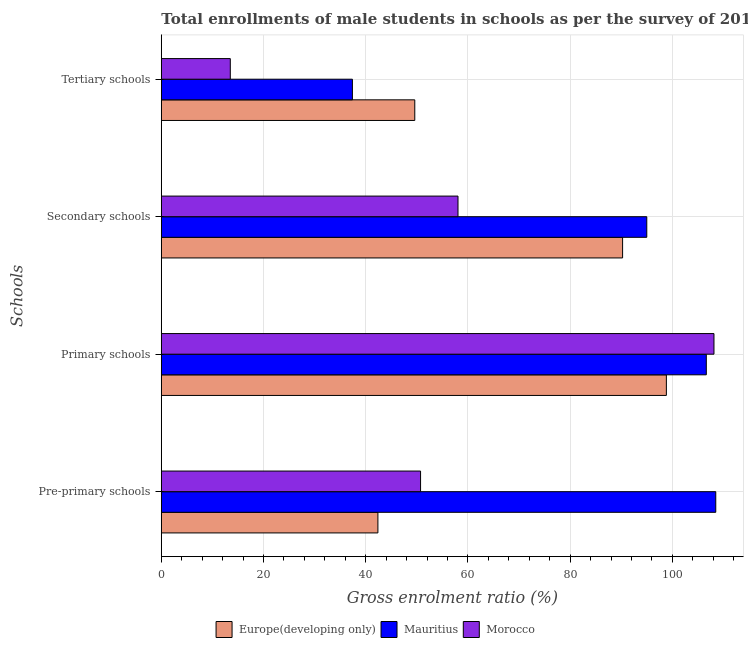How many different coloured bars are there?
Your response must be concise. 3. How many groups of bars are there?
Your answer should be compact. 4. What is the label of the 2nd group of bars from the top?
Make the answer very short. Secondary schools. What is the gross enrolment ratio(male) in primary schools in Morocco?
Offer a very short reply. 108.13. Across all countries, what is the maximum gross enrolment ratio(male) in pre-primary schools?
Make the answer very short. 108.48. Across all countries, what is the minimum gross enrolment ratio(male) in pre-primary schools?
Give a very brief answer. 42.37. In which country was the gross enrolment ratio(male) in primary schools maximum?
Keep it short and to the point. Morocco. In which country was the gross enrolment ratio(male) in primary schools minimum?
Your answer should be very brief. Europe(developing only). What is the total gross enrolment ratio(male) in secondary schools in the graph?
Offer a terse response. 243.27. What is the difference between the gross enrolment ratio(male) in tertiary schools in Morocco and that in Mauritius?
Ensure brevity in your answer.  -23.89. What is the difference between the gross enrolment ratio(male) in pre-primary schools in Europe(developing only) and the gross enrolment ratio(male) in primary schools in Mauritius?
Keep it short and to the point. -64.25. What is the average gross enrolment ratio(male) in tertiary schools per country?
Offer a terse response. 33.49. What is the difference between the gross enrolment ratio(male) in pre-primary schools and gross enrolment ratio(male) in tertiary schools in Morocco?
Your answer should be very brief. 37.22. What is the ratio of the gross enrolment ratio(male) in tertiary schools in Morocco to that in Mauritius?
Offer a terse response. 0.36. Is the gross enrolment ratio(male) in pre-primary schools in Morocco less than that in Mauritius?
Provide a short and direct response. Yes. What is the difference between the highest and the second highest gross enrolment ratio(male) in tertiary schools?
Give a very brief answer. 12.2. What is the difference between the highest and the lowest gross enrolment ratio(male) in primary schools?
Provide a succinct answer. 9.31. What does the 3rd bar from the top in Pre-primary schools represents?
Your answer should be compact. Europe(developing only). What does the 3rd bar from the bottom in Pre-primary schools represents?
Your answer should be very brief. Morocco. Is it the case that in every country, the sum of the gross enrolment ratio(male) in pre-primary schools and gross enrolment ratio(male) in primary schools is greater than the gross enrolment ratio(male) in secondary schools?
Your response must be concise. Yes. Are all the bars in the graph horizontal?
Offer a terse response. Yes. How many countries are there in the graph?
Offer a terse response. 3. What is the difference between two consecutive major ticks on the X-axis?
Your response must be concise. 20. Are the values on the major ticks of X-axis written in scientific E-notation?
Make the answer very short. No. Does the graph contain grids?
Your answer should be compact. Yes. How are the legend labels stacked?
Provide a short and direct response. Horizontal. What is the title of the graph?
Your answer should be very brief. Total enrollments of male students in schools as per the survey of 2010 conducted in different countries. Does "Honduras" appear as one of the legend labels in the graph?
Your response must be concise. No. What is the label or title of the Y-axis?
Provide a succinct answer. Schools. What is the Gross enrolment ratio (%) of Europe(developing only) in Pre-primary schools?
Your answer should be compact. 42.37. What is the Gross enrolment ratio (%) of Mauritius in Pre-primary schools?
Ensure brevity in your answer.  108.48. What is the Gross enrolment ratio (%) of Morocco in Pre-primary schools?
Ensure brevity in your answer.  50.72. What is the Gross enrolment ratio (%) in Europe(developing only) in Primary schools?
Offer a terse response. 98.82. What is the Gross enrolment ratio (%) of Mauritius in Primary schools?
Provide a short and direct response. 106.63. What is the Gross enrolment ratio (%) in Morocco in Primary schools?
Provide a succinct answer. 108.13. What is the Gross enrolment ratio (%) of Europe(developing only) in Secondary schools?
Provide a short and direct response. 90.25. What is the Gross enrolment ratio (%) of Mauritius in Secondary schools?
Give a very brief answer. 94.98. What is the Gross enrolment ratio (%) in Morocco in Secondary schools?
Keep it short and to the point. 58.05. What is the Gross enrolment ratio (%) in Europe(developing only) in Tertiary schools?
Provide a succinct answer. 49.59. What is the Gross enrolment ratio (%) of Mauritius in Tertiary schools?
Make the answer very short. 37.39. What is the Gross enrolment ratio (%) in Morocco in Tertiary schools?
Keep it short and to the point. 13.5. Across all Schools, what is the maximum Gross enrolment ratio (%) in Europe(developing only)?
Make the answer very short. 98.82. Across all Schools, what is the maximum Gross enrolment ratio (%) of Mauritius?
Offer a very short reply. 108.48. Across all Schools, what is the maximum Gross enrolment ratio (%) of Morocco?
Give a very brief answer. 108.13. Across all Schools, what is the minimum Gross enrolment ratio (%) of Europe(developing only)?
Your response must be concise. 42.37. Across all Schools, what is the minimum Gross enrolment ratio (%) in Mauritius?
Keep it short and to the point. 37.39. Across all Schools, what is the minimum Gross enrolment ratio (%) in Morocco?
Your response must be concise. 13.5. What is the total Gross enrolment ratio (%) of Europe(developing only) in the graph?
Give a very brief answer. 281.03. What is the total Gross enrolment ratio (%) of Mauritius in the graph?
Offer a terse response. 347.47. What is the total Gross enrolment ratio (%) of Morocco in the graph?
Give a very brief answer. 230.39. What is the difference between the Gross enrolment ratio (%) of Europe(developing only) in Pre-primary schools and that in Primary schools?
Make the answer very short. -56.44. What is the difference between the Gross enrolment ratio (%) of Mauritius in Pre-primary schools and that in Primary schools?
Offer a very short reply. 1.85. What is the difference between the Gross enrolment ratio (%) of Morocco in Pre-primary schools and that in Primary schools?
Give a very brief answer. -57.41. What is the difference between the Gross enrolment ratio (%) of Europe(developing only) in Pre-primary schools and that in Secondary schools?
Keep it short and to the point. -47.87. What is the difference between the Gross enrolment ratio (%) of Mauritius in Pre-primary schools and that in Secondary schools?
Your response must be concise. 13.5. What is the difference between the Gross enrolment ratio (%) in Morocco in Pre-primary schools and that in Secondary schools?
Give a very brief answer. -7.32. What is the difference between the Gross enrolment ratio (%) in Europe(developing only) in Pre-primary schools and that in Tertiary schools?
Your response must be concise. -7.21. What is the difference between the Gross enrolment ratio (%) in Mauritius in Pre-primary schools and that in Tertiary schools?
Keep it short and to the point. 71.09. What is the difference between the Gross enrolment ratio (%) of Morocco in Pre-primary schools and that in Tertiary schools?
Your answer should be compact. 37.22. What is the difference between the Gross enrolment ratio (%) in Europe(developing only) in Primary schools and that in Secondary schools?
Provide a succinct answer. 8.57. What is the difference between the Gross enrolment ratio (%) of Mauritius in Primary schools and that in Secondary schools?
Offer a very short reply. 11.65. What is the difference between the Gross enrolment ratio (%) in Morocco in Primary schools and that in Secondary schools?
Your answer should be very brief. 50.08. What is the difference between the Gross enrolment ratio (%) in Europe(developing only) in Primary schools and that in Tertiary schools?
Your response must be concise. 49.23. What is the difference between the Gross enrolment ratio (%) of Mauritius in Primary schools and that in Tertiary schools?
Offer a very short reply. 69.24. What is the difference between the Gross enrolment ratio (%) in Morocco in Primary schools and that in Tertiary schools?
Your response must be concise. 94.63. What is the difference between the Gross enrolment ratio (%) in Europe(developing only) in Secondary schools and that in Tertiary schools?
Offer a terse response. 40.66. What is the difference between the Gross enrolment ratio (%) in Mauritius in Secondary schools and that in Tertiary schools?
Provide a short and direct response. 57.59. What is the difference between the Gross enrolment ratio (%) in Morocco in Secondary schools and that in Tertiary schools?
Your answer should be compact. 44.55. What is the difference between the Gross enrolment ratio (%) of Europe(developing only) in Pre-primary schools and the Gross enrolment ratio (%) of Mauritius in Primary schools?
Give a very brief answer. -64.25. What is the difference between the Gross enrolment ratio (%) in Europe(developing only) in Pre-primary schools and the Gross enrolment ratio (%) in Morocco in Primary schools?
Your answer should be compact. -65.75. What is the difference between the Gross enrolment ratio (%) in Mauritius in Pre-primary schools and the Gross enrolment ratio (%) in Morocco in Primary schools?
Ensure brevity in your answer.  0.35. What is the difference between the Gross enrolment ratio (%) in Europe(developing only) in Pre-primary schools and the Gross enrolment ratio (%) in Mauritius in Secondary schools?
Your answer should be very brief. -52.61. What is the difference between the Gross enrolment ratio (%) in Europe(developing only) in Pre-primary schools and the Gross enrolment ratio (%) in Morocco in Secondary schools?
Your answer should be compact. -15.67. What is the difference between the Gross enrolment ratio (%) of Mauritius in Pre-primary schools and the Gross enrolment ratio (%) of Morocco in Secondary schools?
Your answer should be compact. 50.43. What is the difference between the Gross enrolment ratio (%) in Europe(developing only) in Pre-primary schools and the Gross enrolment ratio (%) in Mauritius in Tertiary schools?
Offer a very short reply. 4.99. What is the difference between the Gross enrolment ratio (%) in Europe(developing only) in Pre-primary schools and the Gross enrolment ratio (%) in Morocco in Tertiary schools?
Provide a succinct answer. 28.88. What is the difference between the Gross enrolment ratio (%) in Mauritius in Pre-primary schools and the Gross enrolment ratio (%) in Morocco in Tertiary schools?
Make the answer very short. 94.98. What is the difference between the Gross enrolment ratio (%) of Europe(developing only) in Primary schools and the Gross enrolment ratio (%) of Mauritius in Secondary schools?
Make the answer very short. 3.83. What is the difference between the Gross enrolment ratio (%) of Europe(developing only) in Primary schools and the Gross enrolment ratio (%) of Morocco in Secondary schools?
Your answer should be compact. 40.77. What is the difference between the Gross enrolment ratio (%) of Mauritius in Primary schools and the Gross enrolment ratio (%) of Morocco in Secondary schools?
Give a very brief answer. 48.58. What is the difference between the Gross enrolment ratio (%) in Europe(developing only) in Primary schools and the Gross enrolment ratio (%) in Mauritius in Tertiary schools?
Make the answer very short. 61.43. What is the difference between the Gross enrolment ratio (%) in Europe(developing only) in Primary schools and the Gross enrolment ratio (%) in Morocco in Tertiary schools?
Ensure brevity in your answer.  85.32. What is the difference between the Gross enrolment ratio (%) in Mauritius in Primary schools and the Gross enrolment ratio (%) in Morocco in Tertiary schools?
Provide a short and direct response. 93.13. What is the difference between the Gross enrolment ratio (%) of Europe(developing only) in Secondary schools and the Gross enrolment ratio (%) of Mauritius in Tertiary schools?
Offer a very short reply. 52.86. What is the difference between the Gross enrolment ratio (%) in Europe(developing only) in Secondary schools and the Gross enrolment ratio (%) in Morocco in Tertiary schools?
Make the answer very short. 76.75. What is the difference between the Gross enrolment ratio (%) of Mauritius in Secondary schools and the Gross enrolment ratio (%) of Morocco in Tertiary schools?
Provide a short and direct response. 81.48. What is the average Gross enrolment ratio (%) of Europe(developing only) per Schools?
Your response must be concise. 70.26. What is the average Gross enrolment ratio (%) in Mauritius per Schools?
Ensure brevity in your answer.  86.87. What is the average Gross enrolment ratio (%) in Morocco per Schools?
Keep it short and to the point. 57.6. What is the difference between the Gross enrolment ratio (%) in Europe(developing only) and Gross enrolment ratio (%) in Mauritius in Pre-primary schools?
Provide a short and direct response. -66.1. What is the difference between the Gross enrolment ratio (%) in Europe(developing only) and Gross enrolment ratio (%) in Morocco in Pre-primary schools?
Your answer should be very brief. -8.35. What is the difference between the Gross enrolment ratio (%) of Mauritius and Gross enrolment ratio (%) of Morocco in Pre-primary schools?
Offer a very short reply. 57.76. What is the difference between the Gross enrolment ratio (%) in Europe(developing only) and Gross enrolment ratio (%) in Mauritius in Primary schools?
Offer a very short reply. -7.81. What is the difference between the Gross enrolment ratio (%) of Europe(developing only) and Gross enrolment ratio (%) of Morocco in Primary schools?
Your answer should be very brief. -9.31. What is the difference between the Gross enrolment ratio (%) in Mauritius and Gross enrolment ratio (%) in Morocco in Primary schools?
Make the answer very short. -1.5. What is the difference between the Gross enrolment ratio (%) in Europe(developing only) and Gross enrolment ratio (%) in Mauritius in Secondary schools?
Offer a terse response. -4.73. What is the difference between the Gross enrolment ratio (%) in Europe(developing only) and Gross enrolment ratio (%) in Morocco in Secondary schools?
Provide a short and direct response. 32.2. What is the difference between the Gross enrolment ratio (%) in Mauritius and Gross enrolment ratio (%) in Morocco in Secondary schools?
Your answer should be compact. 36.94. What is the difference between the Gross enrolment ratio (%) of Europe(developing only) and Gross enrolment ratio (%) of Mauritius in Tertiary schools?
Your response must be concise. 12.2. What is the difference between the Gross enrolment ratio (%) of Europe(developing only) and Gross enrolment ratio (%) of Morocco in Tertiary schools?
Make the answer very short. 36.09. What is the difference between the Gross enrolment ratio (%) in Mauritius and Gross enrolment ratio (%) in Morocco in Tertiary schools?
Provide a short and direct response. 23.89. What is the ratio of the Gross enrolment ratio (%) in Europe(developing only) in Pre-primary schools to that in Primary schools?
Your answer should be compact. 0.43. What is the ratio of the Gross enrolment ratio (%) in Mauritius in Pre-primary schools to that in Primary schools?
Offer a very short reply. 1.02. What is the ratio of the Gross enrolment ratio (%) in Morocco in Pre-primary schools to that in Primary schools?
Your answer should be compact. 0.47. What is the ratio of the Gross enrolment ratio (%) of Europe(developing only) in Pre-primary schools to that in Secondary schools?
Give a very brief answer. 0.47. What is the ratio of the Gross enrolment ratio (%) of Mauritius in Pre-primary schools to that in Secondary schools?
Provide a short and direct response. 1.14. What is the ratio of the Gross enrolment ratio (%) in Morocco in Pre-primary schools to that in Secondary schools?
Offer a very short reply. 0.87. What is the ratio of the Gross enrolment ratio (%) of Europe(developing only) in Pre-primary schools to that in Tertiary schools?
Your answer should be compact. 0.85. What is the ratio of the Gross enrolment ratio (%) in Mauritius in Pre-primary schools to that in Tertiary schools?
Offer a terse response. 2.9. What is the ratio of the Gross enrolment ratio (%) in Morocco in Pre-primary schools to that in Tertiary schools?
Offer a very short reply. 3.76. What is the ratio of the Gross enrolment ratio (%) of Europe(developing only) in Primary schools to that in Secondary schools?
Make the answer very short. 1.09. What is the ratio of the Gross enrolment ratio (%) of Mauritius in Primary schools to that in Secondary schools?
Ensure brevity in your answer.  1.12. What is the ratio of the Gross enrolment ratio (%) in Morocco in Primary schools to that in Secondary schools?
Make the answer very short. 1.86. What is the ratio of the Gross enrolment ratio (%) in Europe(developing only) in Primary schools to that in Tertiary schools?
Provide a succinct answer. 1.99. What is the ratio of the Gross enrolment ratio (%) in Mauritius in Primary schools to that in Tertiary schools?
Offer a terse response. 2.85. What is the ratio of the Gross enrolment ratio (%) of Morocco in Primary schools to that in Tertiary schools?
Your answer should be compact. 8.01. What is the ratio of the Gross enrolment ratio (%) of Europe(developing only) in Secondary schools to that in Tertiary schools?
Provide a short and direct response. 1.82. What is the ratio of the Gross enrolment ratio (%) of Mauritius in Secondary schools to that in Tertiary schools?
Your answer should be very brief. 2.54. What is the ratio of the Gross enrolment ratio (%) in Morocco in Secondary schools to that in Tertiary schools?
Your answer should be very brief. 4.3. What is the difference between the highest and the second highest Gross enrolment ratio (%) in Europe(developing only)?
Provide a short and direct response. 8.57. What is the difference between the highest and the second highest Gross enrolment ratio (%) of Mauritius?
Keep it short and to the point. 1.85. What is the difference between the highest and the second highest Gross enrolment ratio (%) of Morocco?
Offer a very short reply. 50.08. What is the difference between the highest and the lowest Gross enrolment ratio (%) of Europe(developing only)?
Offer a very short reply. 56.44. What is the difference between the highest and the lowest Gross enrolment ratio (%) in Mauritius?
Your response must be concise. 71.09. What is the difference between the highest and the lowest Gross enrolment ratio (%) in Morocco?
Your answer should be compact. 94.63. 